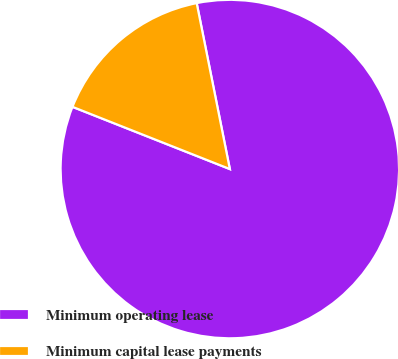Convert chart to OTSL. <chart><loc_0><loc_0><loc_500><loc_500><pie_chart><fcel>Minimum operating lease<fcel>Minimum capital lease payments<nl><fcel>84.13%<fcel>15.87%<nl></chart> 